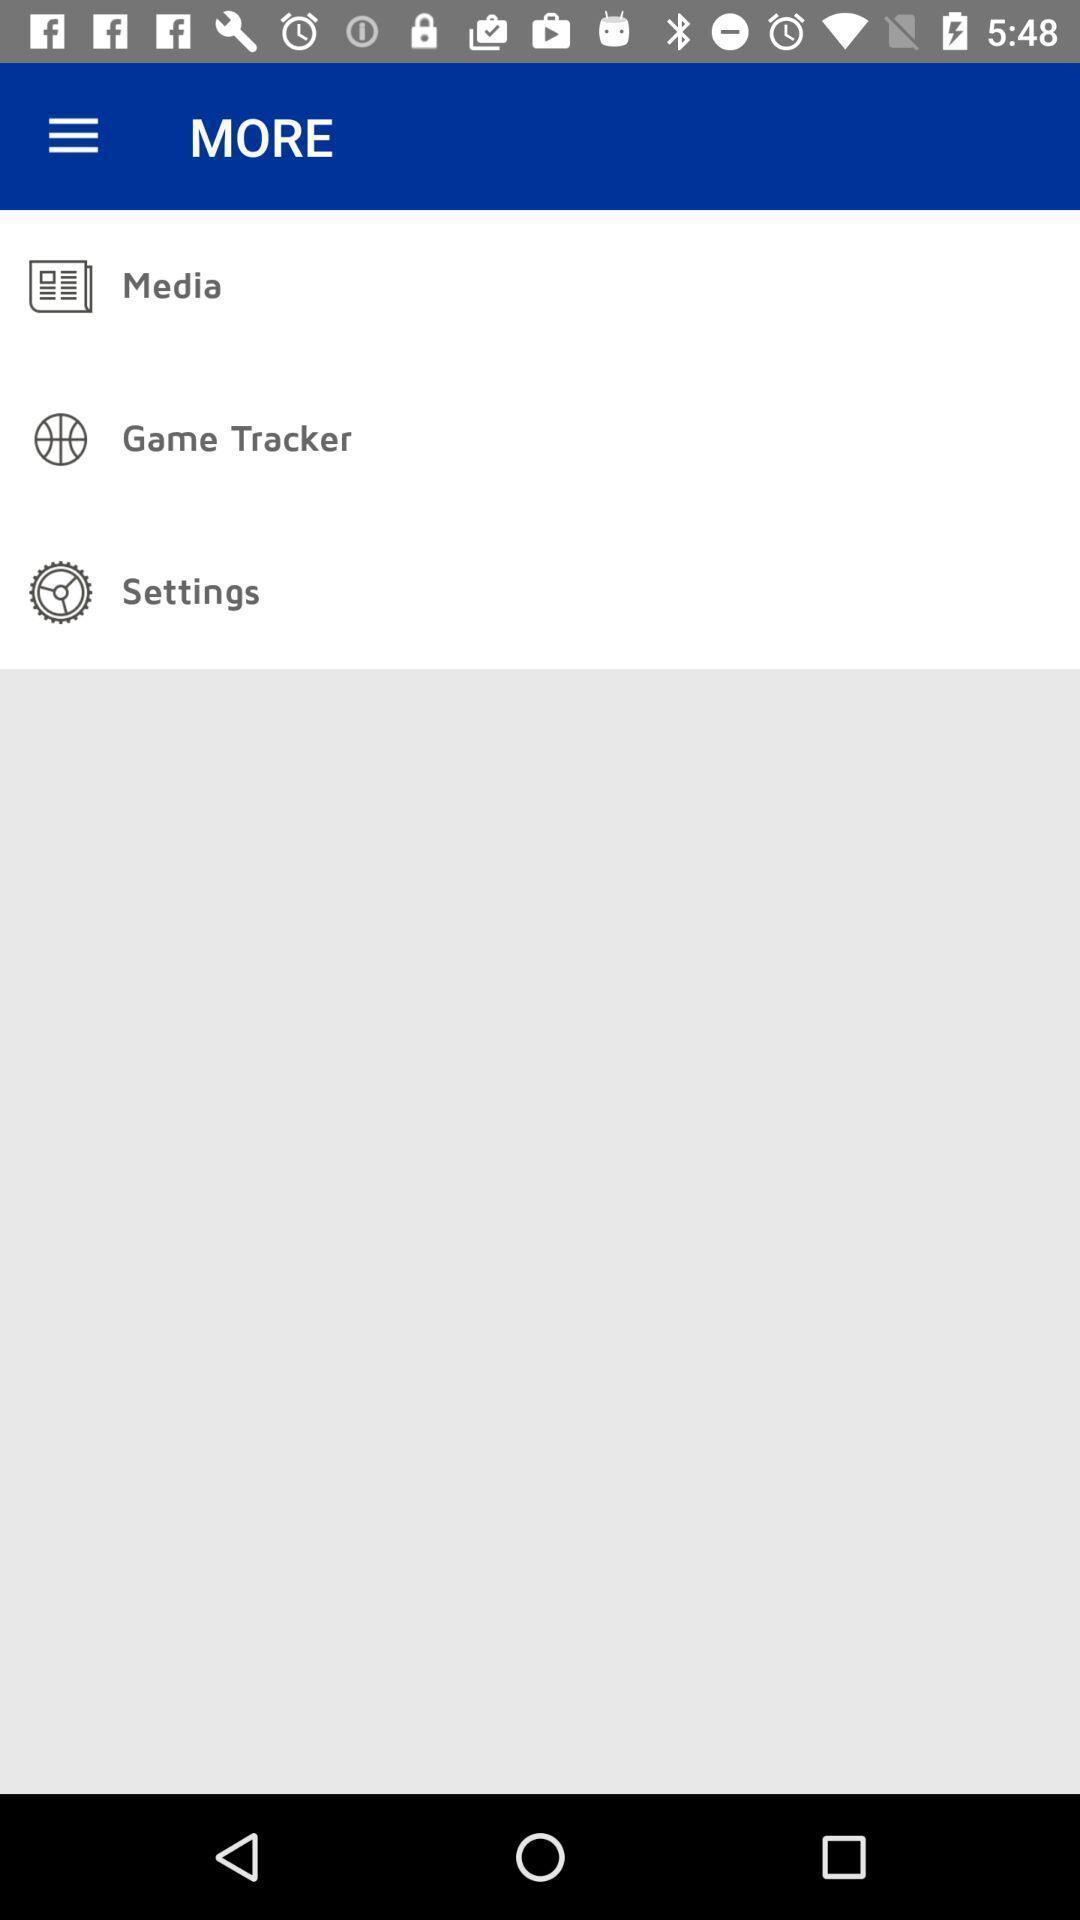Describe this image in words. Page displaying options under more. 